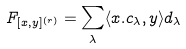<formula> <loc_0><loc_0><loc_500><loc_500>\ F _ { [ x , y ] ^ { ( r ) } } = \sum _ { \lambda } \langle x . c _ { \lambda } , y \rangle d _ { \lambda }</formula> 